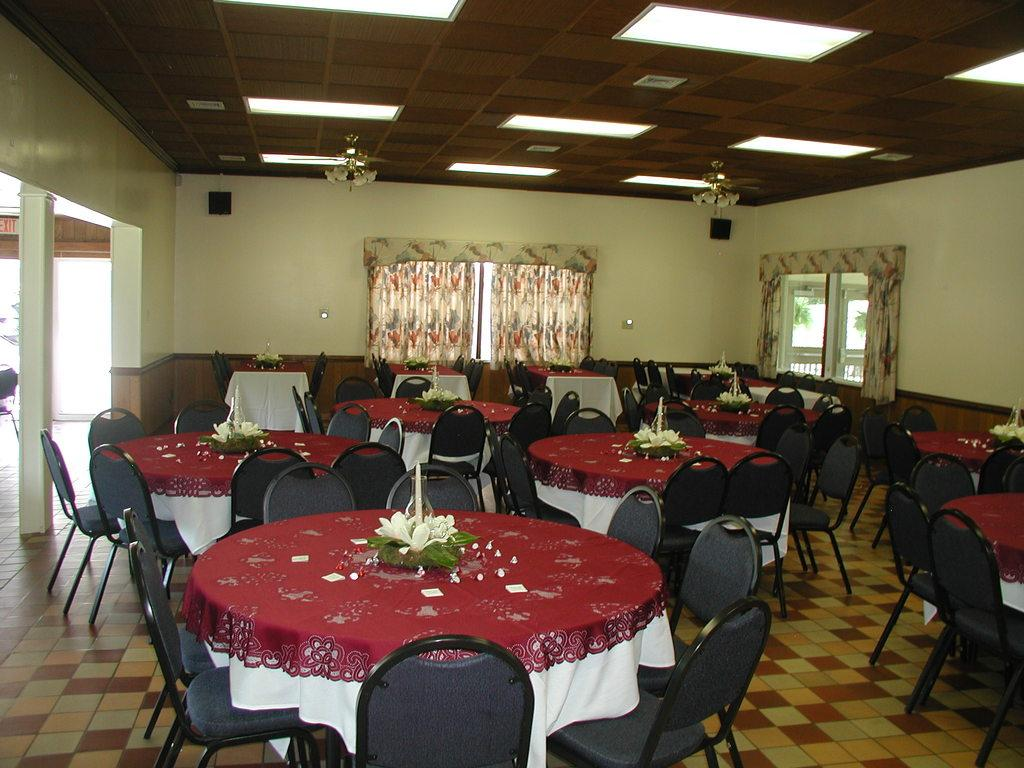What type of furniture is present in the image? There are tables and chairs in the image. What decorative item can be seen in the image? There is a flower vase in the image. What type of window treatment is present in the image? There are curtains in the image. What type of audio equipment is present in the image? There are speakers in the image. What type of cooling device is present in the image? There are fans in the image. What type of lighting is present in the image? There are tube lights in the image. What architectural feature is present in the image? There are windows in the image. What type of structure is present in the image? There is a wall in the image. What type of print is visible on the wall in the image? There is no print visible on the wall in the image. What type of kettle is present in the image? There is no kettle present in the image. 